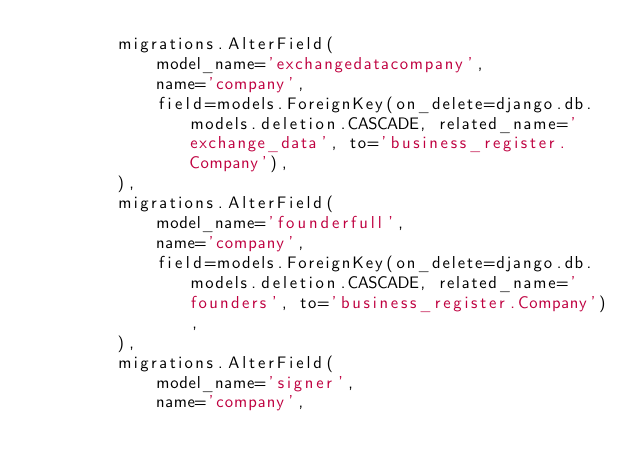Convert code to text. <code><loc_0><loc_0><loc_500><loc_500><_Python_>        migrations.AlterField(
            model_name='exchangedatacompany',
            name='company',
            field=models.ForeignKey(on_delete=django.db.models.deletion.CASCADE, related_name='exchange_data', to='business_register.Company'),
        ),
        migrations.AlterField(
            model_name='founderfull',
            name='company',
            field=models.ForeignKey(on_delete=django.db.models.deletion.CASCADE, related_name='founders', to='business_register.Company'),
        ),
        migrations.AlterField(
            model_name='signer',
            name='company',</code> 